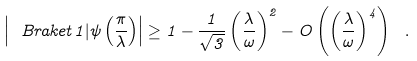Convert formula to latex. <formula><loc_0><loc_0><loc_500><loc_500>\left | \ B r a k e t { 1 | \psi \left ( \frac { \pi } { \lambda } \right ) } \right | \geq 1 - \frac { 1 } { \sqrt { 3 } } \left ( \frac { \lambda } { \omega } \right ) ^ { 2 } - O \left ( \left ( \frac { \lambda } { \omega } \right ) ^ { 4 } \right ) \ .</formula> 